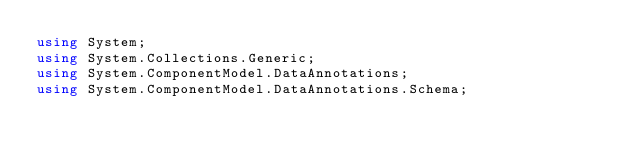<code> <loc_0><loc_0><loc_500><loc_500><_C#_>using System;
using System.Collections.Generic;
using System.ComponentModel.DataAnnotations;
using System.ComponentModel.DataAnnotations.Schema;
</code> 